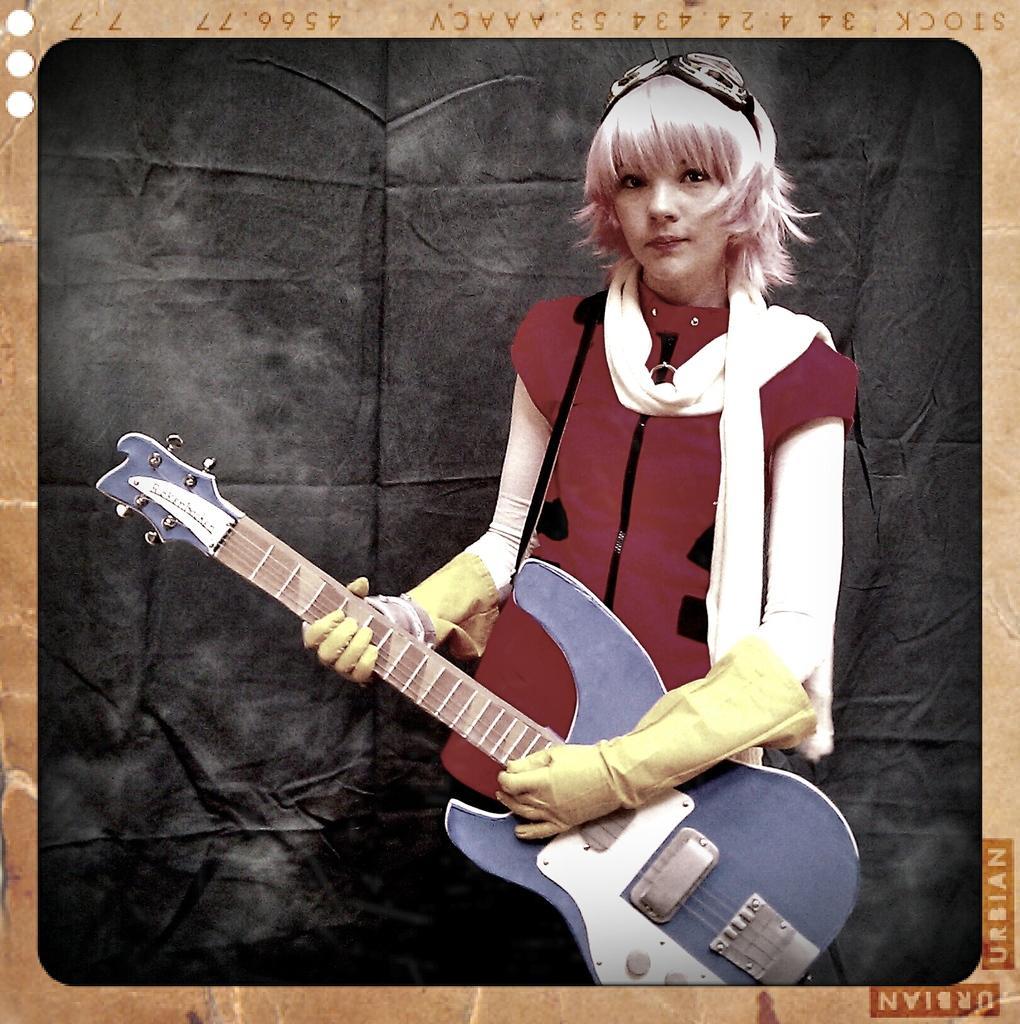In one or two sentences, can you explain what this image depicts? In the picture we can find a woman holding a guitar and she wore yellow gloves and red shirt. In the background we can find a black curtain and it is a photo frame. 